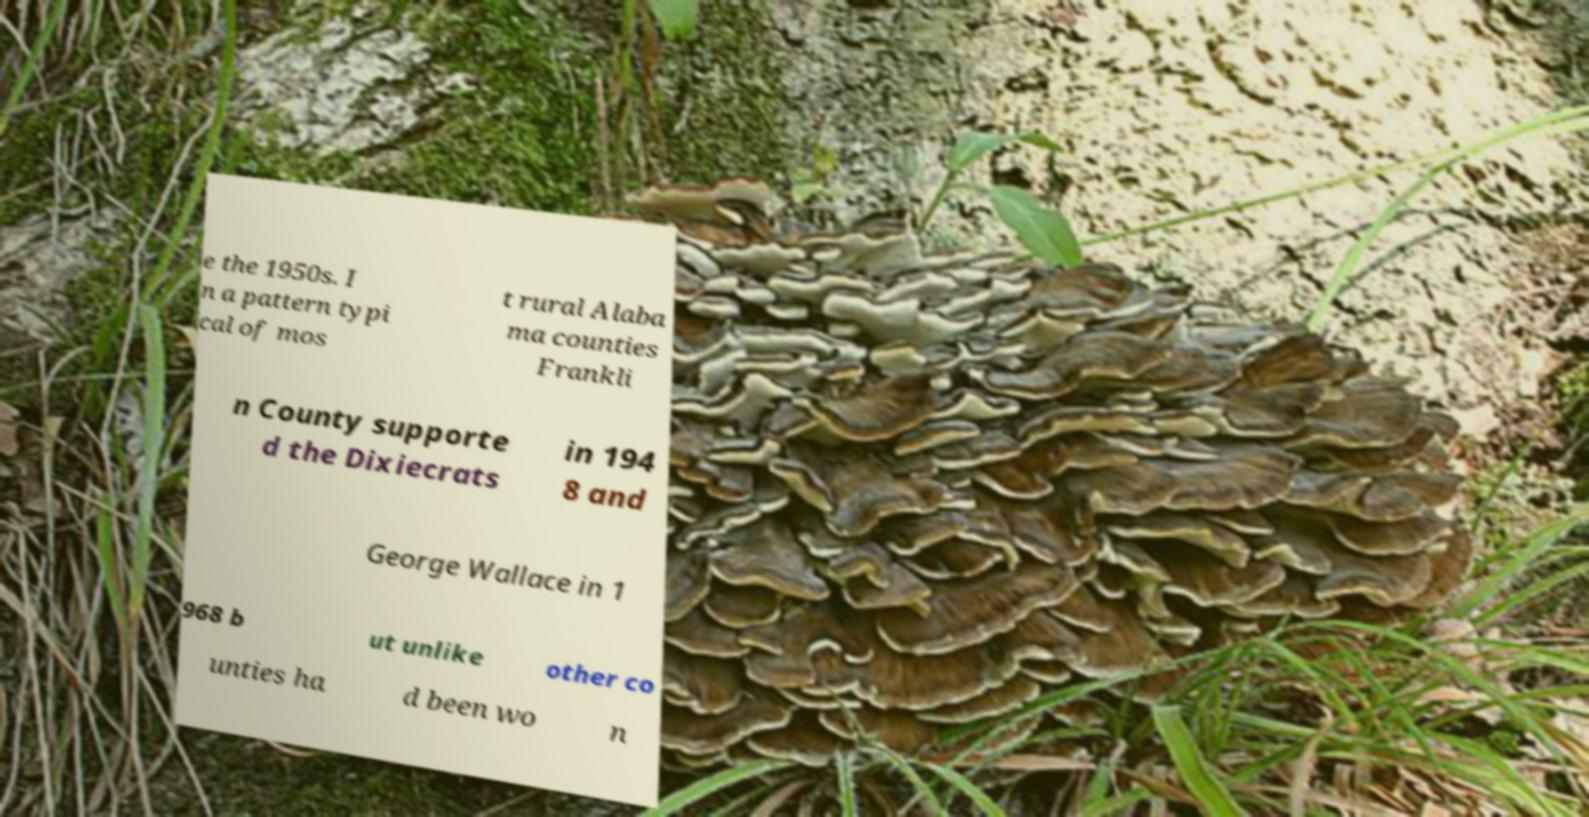What messages or text are displayed in this image? I need them in a readable, typed format. e the 1950s. I n a pattern typi cal of mos t rural Alaba ma counties Frankli n County supporte d the Dixiecrats in 194 8 and George Wallace in 1 968 b ut unlike other co unties ha d been wo n 